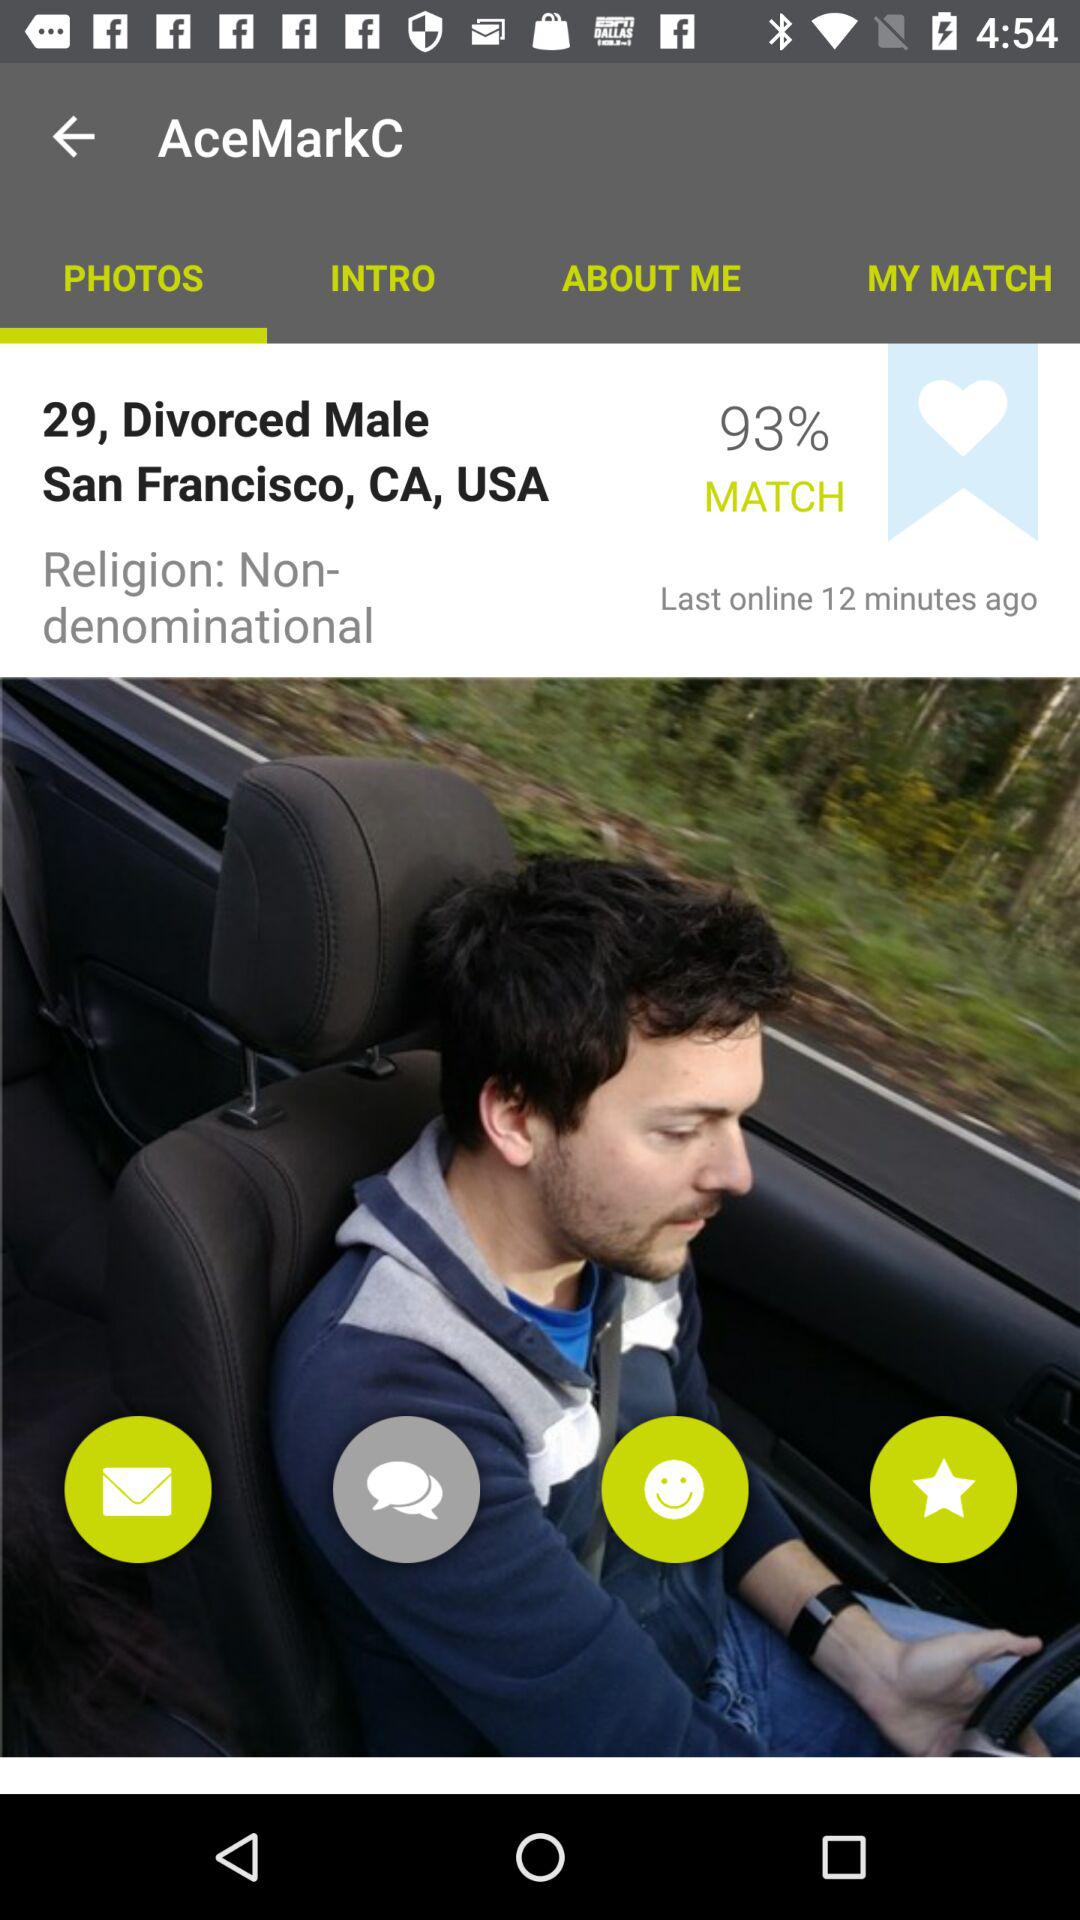What is the age of the person? The age of the person is 29. 